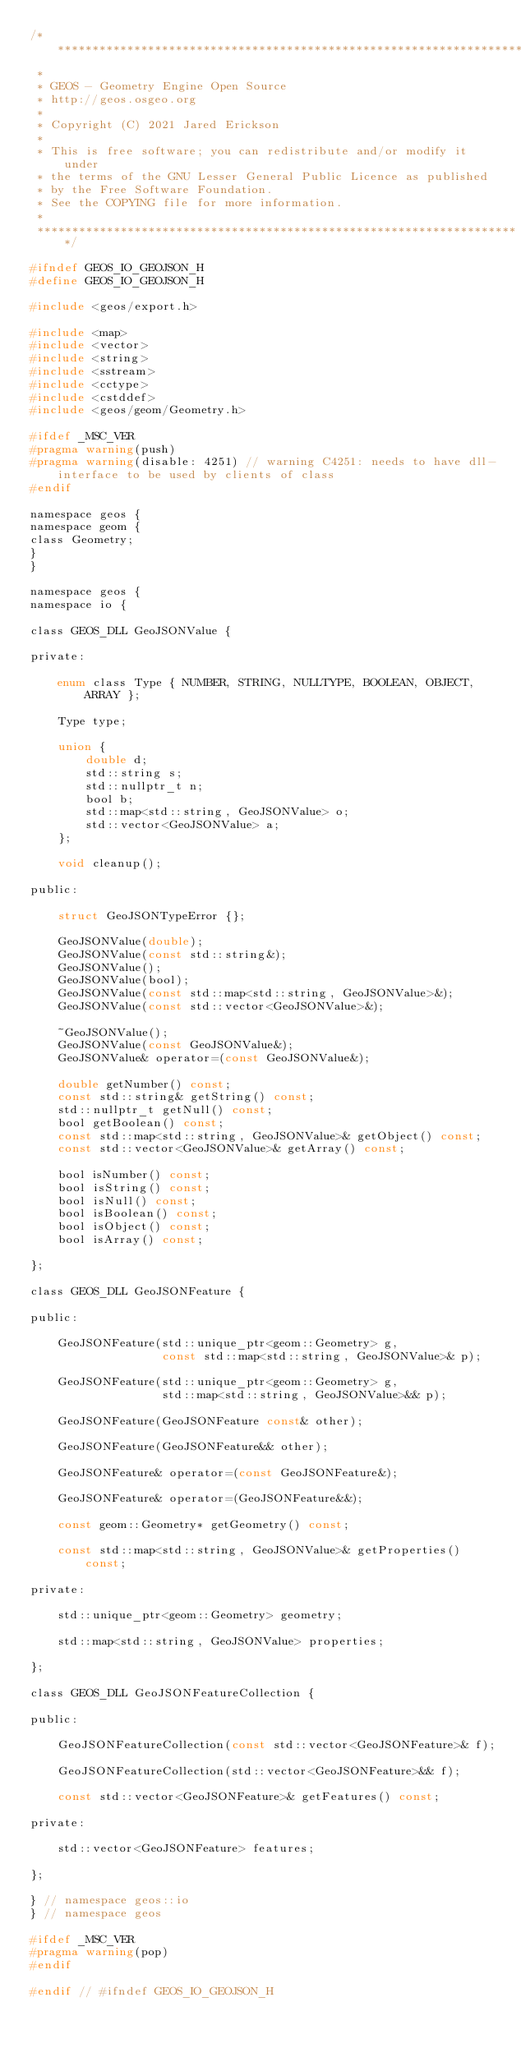<code> <loc_0><loc_0><loc_500><loc_500><_C_>/**********************************************************************
 *
 * GEOS - Geometry Engine Open Source
 * http://geos.osgeo.org
 *
 * Copyright (C) 2021 Jared Erickson
 *
 * This is free software; you can redistribute and/or modify it under
 * the terms of the GNU Lesser General Public Licence as published
 * by the Free Software Foundation.
 * See the COPYING file for more information.
 *
 **********************************************************************/

#ifndef GEOS_IO_GEOJSON_H
#define GEOS_IO_GEOJSON_H

#include <geos/export.h>

#include <map>
#include <vector>
#include <string>
#include <sstream>
#include <cctype>
#include <cstddef>
#include <geos/geom/Geometry.h>

#ifdef _MSC_VER
#pragma warning(push)
#pragma warning(disable: 4251) // warning C4251: needs to have dll-interface to be used by clients of class
#endif

namespace geos {
namespace geom {
class Geometry;
}
}

namespace geos {
namespace io {

class GEOS_DLL GeoJSONValue {

private:

    enum class Type { NUMBER, STRING, NULLTYPE, BOOLEAN, OBJECT, ARRAY };

    Type type;

    union {
        double d;
        std::string s;
        std::nullptr_t n;
        bool b;
        std::map<std::string, GeoJSONValue> o;
        std::vector<GeoJSONValue> a;
    };

    void cleanup();

public:

    struct GeoJSONTypeError {};

    GeoJSONValue(double);
    GeoJSONValue(const std::string&);
    GeoJSONValue();
    GeoJSONValue(bool);
    GeoJSONValue(const std::map<std::string, GeoJSONValue>&);
    GeoJSONValue(const std::vector<GeoJSONValue>&);

    ~GeoJSONValue();
    GeoJSONValue(const GeoJSONValue&);
    GeoJSONValue& operator=(const GeoJSONValue&);

    double getNumber() const;
    const std::string& getString() const;
    std::nullptr_t getNull() const;
    bool getBoolean() const;
    const std::map<std::string, GeoJSONValue>& getObject() const;
    const std::vector<GeoJSONValue>& getArray() const;

    bool isNumber() const;
    bool isString() const;
    bool isNull() const;
    bool isBoolean() const;
    bool isObject() const;
    bool isArray() const;

};

class GEOS_DLL GeoJSONFeature {

public:

    GeoJSONFeature(std::unique_ptr<geom::Geometry> g,
                   const std::map<std::string, GeoJSONValue>& p);

    GeoJSONFeature(std::unique_ptr<geom::Geometry> g,
                   std::map<std::string, GeoJSONValue>&& p);

    GeoJSONFeature(GeoJSONFeature const& other);

    GeoJSONFeature(GeoJSONFeature&& other);

    GeoJSONFeature& operator=(const GeoJSONFeature&);

    GeoJSONFeature& operator=(GeoJSONFeature&&);

    const geom::Geometry* getGeometry() const;

    const std::map<std::string, GeoJSONValue>& getProperties() const;

private:

    std::unique_ptr<geom::Geometry> geometry;

    std::map<std::string, GeoJSONValue> properties;

};

class GEOS_DLL GeoJSONFeatureCollection {

public:

    GeoJSONFeatureCollection(const std::vector<GeoJSONFeature>& f);

    GeoJSONFeatureCollection(std::vector<GeoJSONFeature>&& f);

    const std::vector<GeoJSONFeature>& getFeatures() const;

private:

    std::vector<GeoJSONFeature> features;

};

} // namespace geos::io
} // namespace geos

#ifdef _MSC_VER
#pragma warning(pop)
#endif

#endif // #ifndef GEOS_IO_GEOJSON_H
</code> 